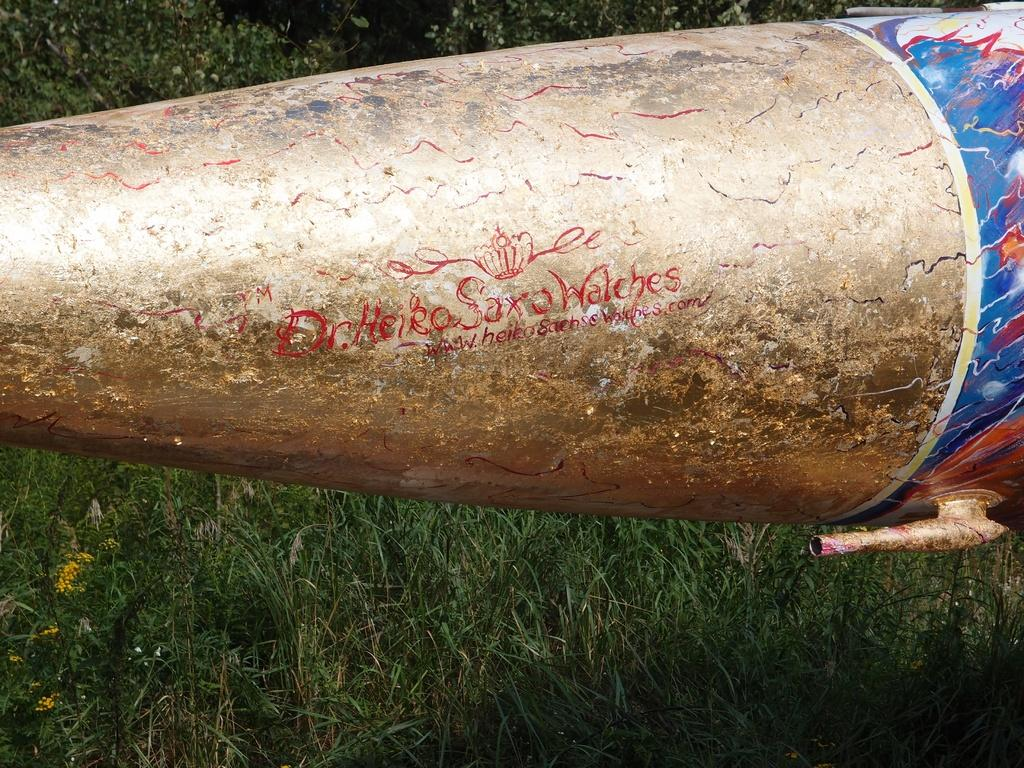What is the main subject of the image? There is a rocket in the center of the image. What can be seen in the background of the image? There is grass visible in the background of the image. How many cows are present at the event depicted in the image? There is no event depicted in the image, and no cows are present. 